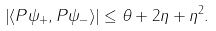<formula> <loc_0><loc_0><loc_500><loc_500>\left | \langle P \psi _ { + } , P \psi _ { - } \rangle \right | \leq \theta + 2 \eta + \eta ^ { 2 } .</formula> 